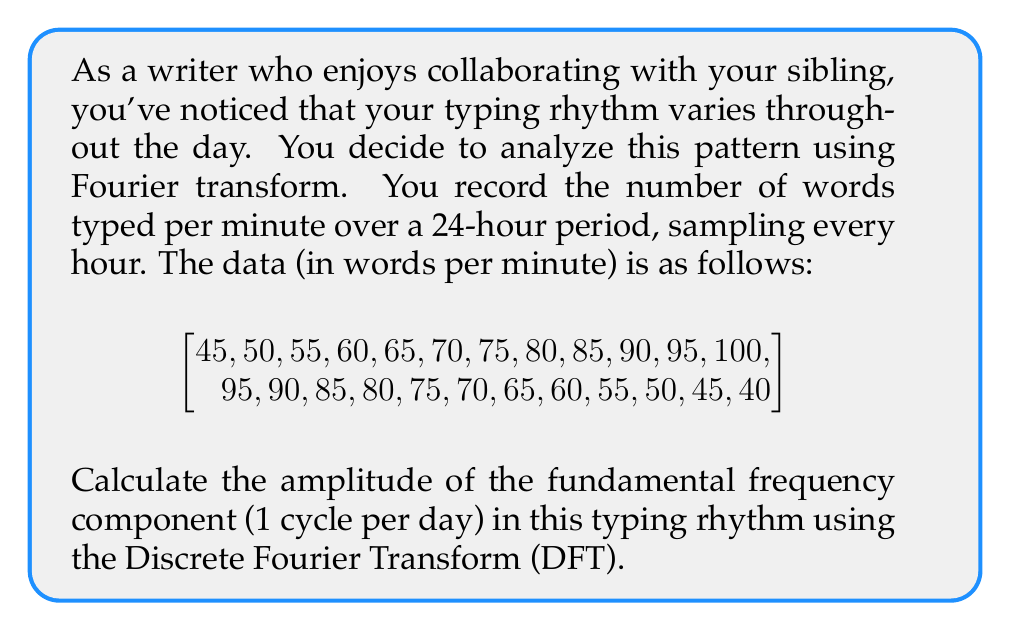Can you answer this question? To solve this problem, we'll follow these steps:

1) The Discrete Fourier Transform (DFT) for a sequence $x[n]$ of length $N$ is given by:

   $$X[k] = \sum_{n=0}^{N-1} x[n] \cdot e^{-i2\pi kn/N}$$

2) For the fundamental frequency (1 cycle per day), $k = 1$. We have $N = 24$ samples.

3) We need to calculate the real and imaginary parts separately:

   $$X[1] = \sum_{n=0}^{23} x[n] \cdot (\cos(2\pi n/24) - i \sin(2\pi n/24))$$

4) Let's calculate the real part first:

   $$\text{Re}(X[1]) = \sum_{n=0}^{23} x[n] \cdot \cos(2\pi n/24)$$

5) And the imaginary part:

   $$\text{Im}(X[1]) = -\sum_{n=0}^{23} x[n] \cdot \sin(2\pi n/24)$$

6) Calculating these sums (which can be done with a calculator or computer):

   $\text{Re}(X[1]) \approx -180$
   $\text{Im}(X[1]) \approx -311.77$

7) The amplitude of this frequency component is given by:

   $$|X[1]| = \sqrt{(\text{Re}(X[1]))^2 + (\text{Im}(X[1]))^2}$$

8) Substituting the values:

   $$|X[1]| = \sqrt{(-180)^2 + (-311.77)^2} \approx 360.04$$

9) To get the actual amplitude, we need to divide this by $N/2 = 12$:

   $$\text{Amplitude} = \frac{|X[1]|}{12} \approx 30.00$$
Answer: The amplitude of the fundamental frequency component (1 cycle per day) in the typing rhythm is approximately 30.00 words per minute. 